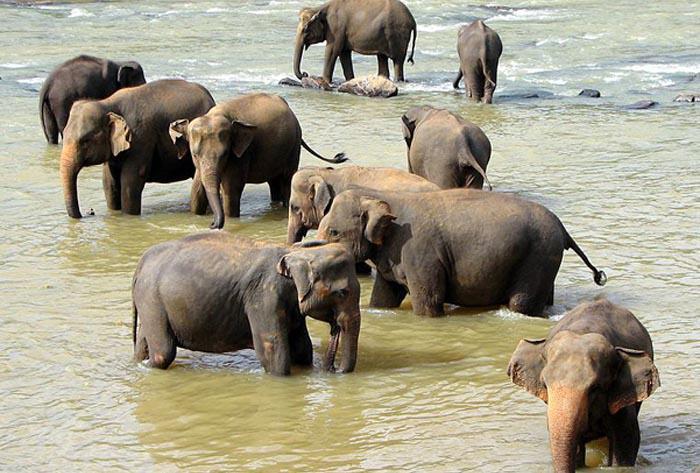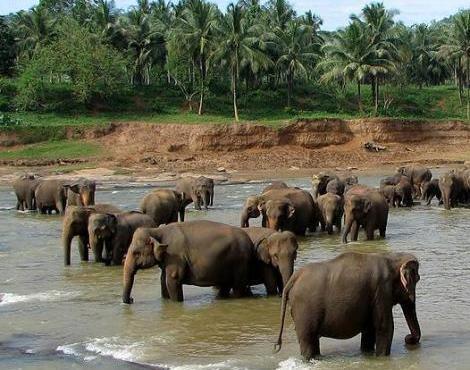The first image is the image on the left, the second image is the image on the right. For the images shown, is this caption "There is exactly one elephant in the image on the right." true? Answer yes or no. No. 